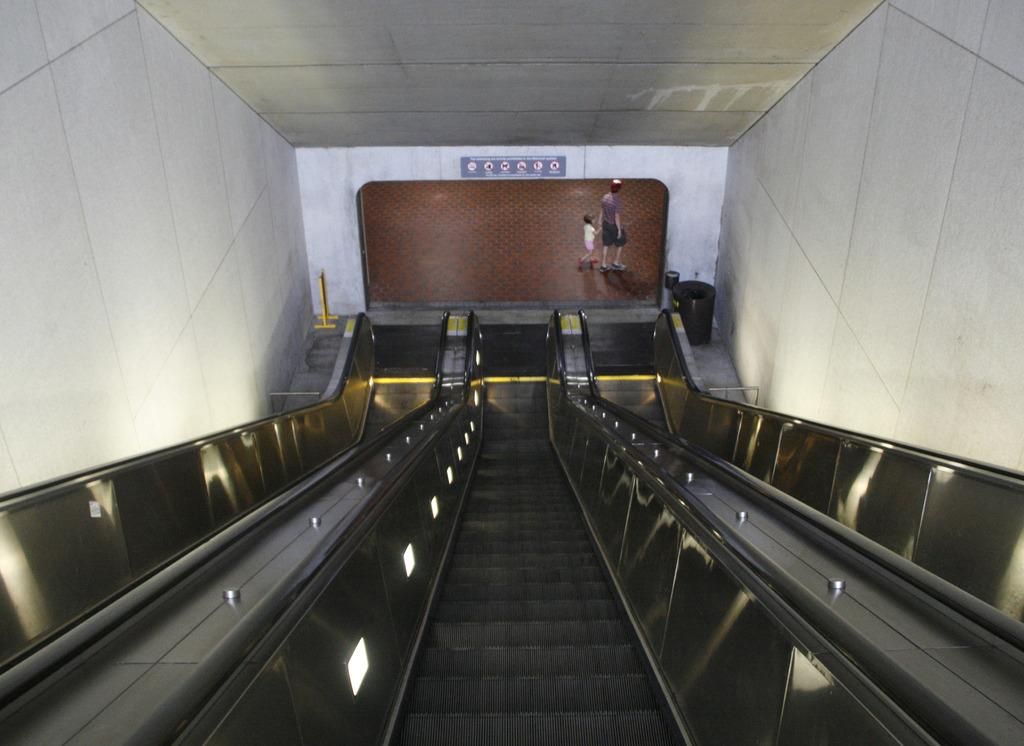What type of transportation is present in the image? There are escalators in the image. Can you describe the people in the image? There is a person walking and a kid walking in the image. What is the surrounding environment like in the image? There are walls on both the right and left sides of the image. What is the temperature outside during the summer season in the image? The provided facts do not mention any information about the temperature or the season, so it cannot be determined from the image. 